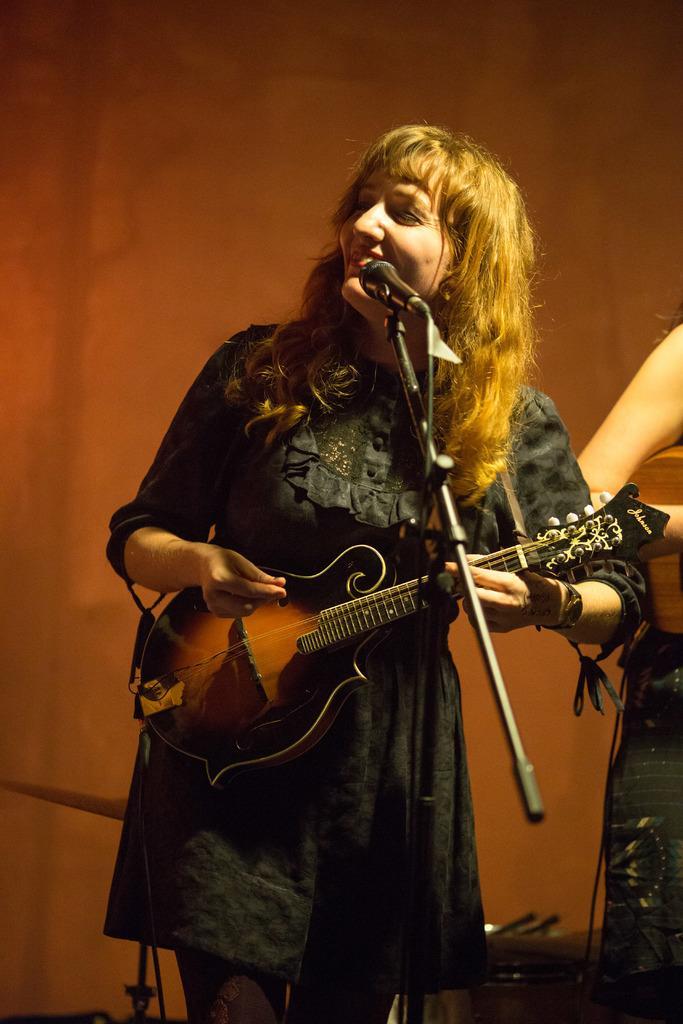Please provide a concise description of this image. In this picture a woman is highlighted holding a pretty smile on her face. She is standing in front of a mike and playing a guitar. 